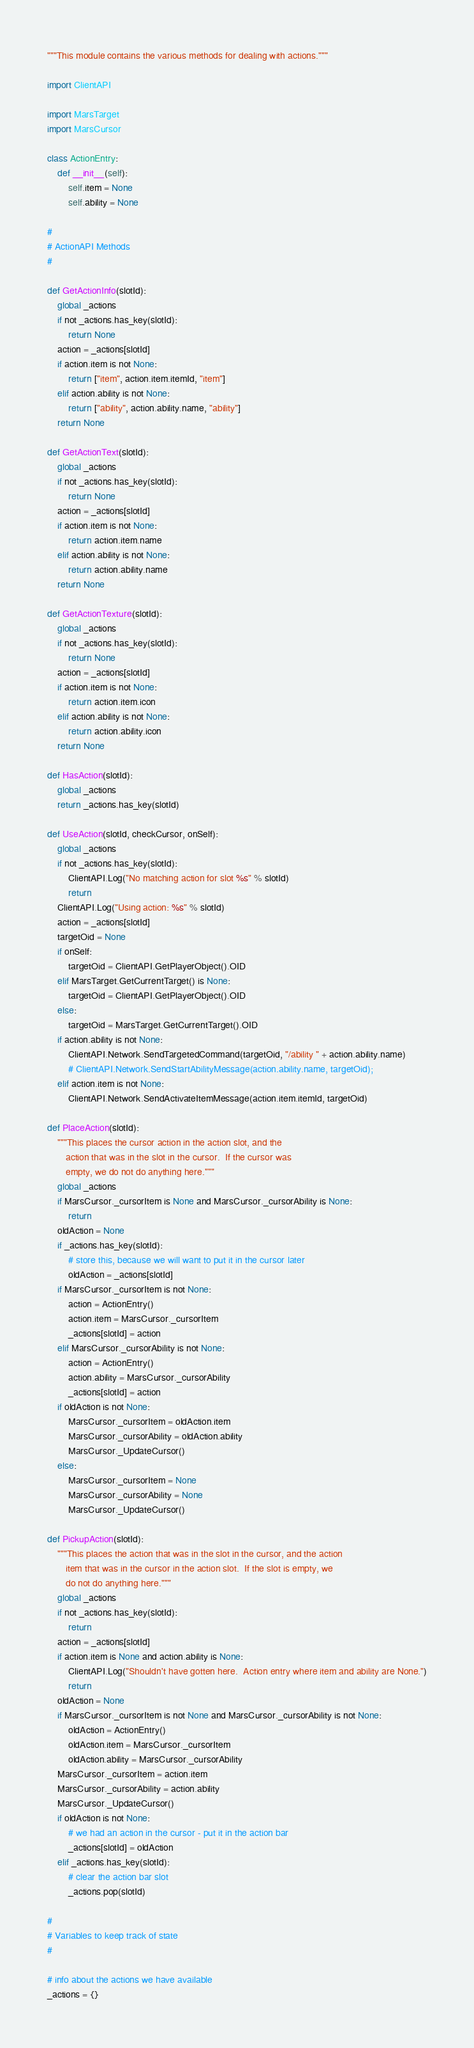Convert code to text. <code><loc_0><loc_0><loc_500><loc_500><_Python_>"""This module contains the various methods for dealing with actions."""

import ClientAPI

import MarsTarget
import MarsCursor

class ActionEntry:
    def __init__(self):
        self.item = None
        self.ability = None

#
# ActionAPI Methods
#

def GetActionInfo(slotId):
    global _actions
    if not _actions.has_key(slotId):
        return None
    action = _actions[slotId]
    if action.item is not None:
        return ["item", action.item.itemId, "item"]
    elif action.ability is not None:
        return ["ability", action.ability.name, "ability"]
    return None

def GetActionText(slotId):
    global _actions
    if not _actions.has_key(slotId):
        return None
    action = _actions[slotId]
    if action.item is not None:
        return action.item.name
    elif action.ability is not None:
        return action.ability.name
    return None

def GetActionTexture(slotId):
    global _actions
    if not _actions.has_key(slotId):
        return None
    action = _actions[slotId]
    if action.item is not None:
        return action.item.icon
    elif action.ability is not None:
        return action.ability.icon
    return None

def HasAction(slotId):
    global _actions
    return _actions.has_key(slotId)

def UseAction(slotId, checkCursor, onSelf):
    global _actions
    if not _actions.has_key(slotId):
        ClientAPI.Log("No matching action for slot %s" % slotId)
        return
    ClientAPI.Log("Using action: %s" % slotId)
    action = _actions[slotId]
    targetOid = None
    if onSelf:
        targetOid = ClientAPI.GetPlayerObject().OID
    elif MarsTarget.GetCurrentTarget() is None:
        targetOid = ClientAPI.GetPlayerObject().OID
    else:
        targetOid = MarsTarget.GetCurrentTarget().OID
    if action.ability is not None:
        ClientAPI.Network.SendTargetedCommand(targetOid, "/ability " + action.ability.name)
        # ClientAPI.Network.SendStartAbilityMessage(action.ability.name, targetOid);
    elif action.item is not None:
        ClientAPI.Network.SendActivateItemMessage(action.item.itemId, targetOid)

def PlaceAction(slotId):
    """This places the cursor action in the action slot, and the
       action that was in the slot in the cursor.  If the cursor was
       empty, we do not do anything here."""
    global _actions
    if MarsCursor._cursorItem is None and MarsCursor._cursorAbility is None:
        return
    oldAction = None
    if _actions.has_key(slotId):
        # store this, because we will want to put it in the cursor later
        oldAction = _actions[slotId]
    if MarsCursor._cursorItem is not None:
        action = ActionEntry()
        action.item = MarsCursor._cursorItem
        _actions[slotId] = action
    elif MarsCursor._cursorAbility is not None:
        action = ActionEntry()
        action.ability = MarsCursor._cursorAbility
        _actions[slotId] = action
    if oldAction is not None:
        MarsCursor._cursorItem = oldAction.item
        MarsCursor._cursorAbility = oldAction.ability
        MarsCursor._UpdateCursor()
    else:
        MarsCursor._cursorItem = None
        MarsCursor._cursorAbility = None
        MarsCursor._UpdateCursor()

def PickupAction(slotId):
    """This places the action that was in the slot in the cursor, and the action
       item that was in the cursor in the action slot.  If the slot is empty, we
       do not do anything here."""
    global _actions
    if not _actions.has_key(slotId):
        return
    action = _actions[slotId]
    if action.item is None and action.ability is None:
        ClientAPI.Log("Shouldn't have gotten here.  Action entry where item and ability are None.")
        return
    oldAction = None
    if MarsCursor._cursorItem is not None and MarsCursor._cursorAbility is not None:
        oldAction = ActionEntry()
        oldAction.item = MarsCursor._cursorItem
        oldAction.ability = MarsCursor._cursorAbility
    MarsCursor._cursorItem = action.item
    MarsCursor._cursorAbility = action.ability
    MarsCursor._UpdateCursor()
    if oldAction is not None:
        # we had an action in the cursor - put it in the action bar
        _actions[slotId] = oldAction
    elif _actions.has_key(slotId):
        # clear the action bar slot
        _actions.pop(slotId)

#
# Variables to keep track of state
#

# info about the actions we have available
_actions = {}

</code> 